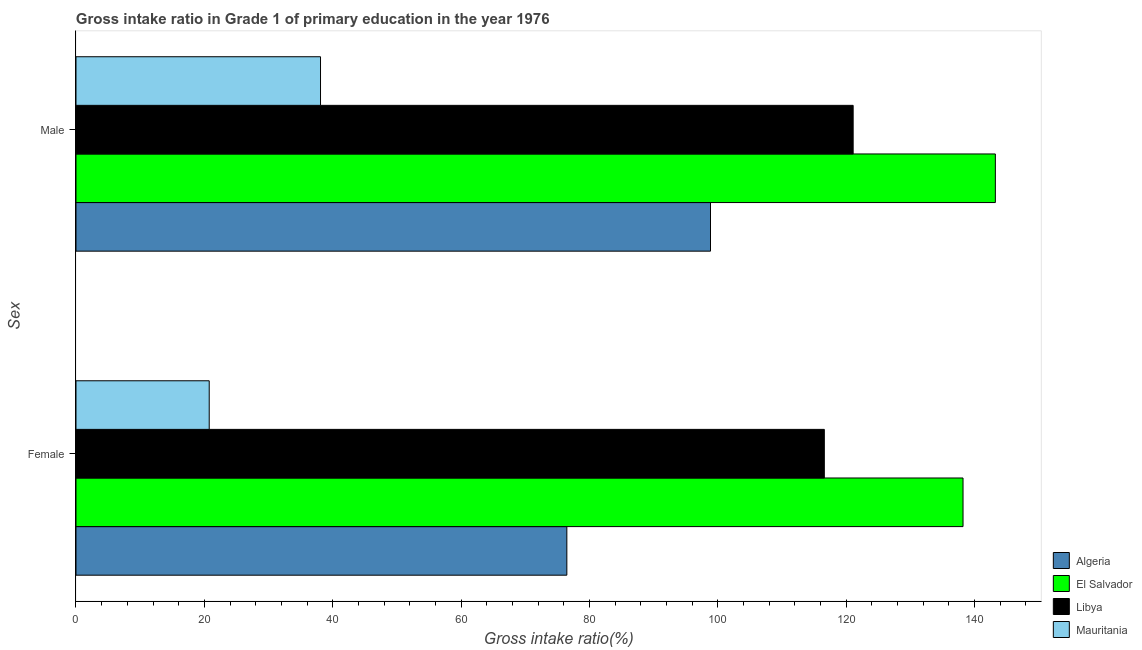How many different coloured bars are there?
Offer a terse response. 4. Are the number of bars per tick equal to the number of legend labels?
Give a very brief answer. Yes. How many bars are there on the 1st tick from the top?
Ensure brevity in your answer.  4. What is the gross intake ratio(male) in Libya?
Your answer should be compact. 121.1. Across all countries, what is the maximum gross intake ratio(female)?
Ensure brevity in your answer.  138.22. Across all countries, what is the minimum gross intake ratio(male)?
Provide a short and direct response. 38.1. In which country was the gross intake ratio(male) maximum?
Provide a short and direct response. El Salvador. In which country was the gross intake ratio(female) minimum?
Your answer should be very brief. Mauritania. What is the total gross intake ratio(female) in the graph?
Keep it short and to the point. 352.07. What is the difference between the gross intake ratio(male) in Libya and that in El Salvador?
Keep it short and to the point. -22.16. What is the difference between the gross intake ratio(female) in Algeria and the gross intake ratio(male) in Libya?
Offer a very short reply. -44.61. What is the average gross intake ratio(male) per country?
Offer a terse response. 100.33. What is the difference between the gross intake ratio(male) and gross intake ratio(female) in Algeria?
Your answer should be compact. 22.39. What is the ratio of the gross intake ratio(female) in Mauritania to that in Algeria?
Your answer should be very brief. 0.27. Is the gross intake ratio(female) in Algeria less than that in Mauritania?
Keep it short and to the point. No. What does the 2nd bar from the top in Female represents?
Ensure brevity in your answer.  Libya. What does the 4th bar from the bottom in Female represents?
Your response must be concise. Mauritania. How many bars are there?
Your response must be concise. 8. How many countries are there in the graph?
Ensure brevity in your answer.  4. Does the graph contain grids?
Offer a terse response. No. Where does the legend appear in the graph?
Keep it short and to the point. Bottom right. How many legend labels are there?
Provide a short and direct response. 4. How are the legend labels stacked?
Offer a terse response. Vertical. What is the title of the graph?
Give a very brief answer. Gross intake ratio in Grade 1 of primary education in the year 1976. What is the label or title of the X-axis?
Make the answer very short. Gross intake ratio(%). What is the label or title of the Y-axis?
Your answer should be very brief. Sex. What is the Gross intake ratio(%) of Algeria in Female?
Provide a short and direct response. 76.48. What is the Gross intake ratio(%) in El Salvador in Female?
Make the answer very short. 138.22. What is the Gross intake ratio(%) of Libya in Female?
Keep it short and to the point. 116.61. What is the Gross intake ratio(%) in Mauritania in Female?
Offer a very short reply. 20.76. What is the Gross intake ratio(%) in Algeria in Male?
Your response must be concise. 98.87. What is the Gross intake ratio(%) in El Salvador in Male?
Offer a very short reply. 143.26. What is the Gross intake ratio(%) of Libya in Male?
Your answer should be compact. 121.1. What is the Gross intake ratio(%) in Mauritania in Male?
Give a very brief answer. 38.1. Across all Sex, what is the maximum Gross intake ratio(%) of Algeria?
Offer a terse response. 98.87. Across all Sex, what is the maximum Gross intake ratio(%) in El Salvador?
Provide a succinct answer. 143.26. Across all Sex, what is the maximum Gross intake ratio(%) of Libya?
Your answer should be very brief. 121.1. Across all Sex, what is the maximum Gross intake ratio(%) of Mauritania?
Provide a short and direct response. 38.1. Across all Sex, what is the minimum Gross intake ratio(%) of Algeria?
Provide a succinct answer. 76.48. Across all Sex, what is the minimum Gross intake ratio(%) in El Salvador?
Make the answer very short. 138.22. Across all Sex, what is the minimum Gross intake ratio(%) in Libya?
Ensure brevity in your answer.  116.61. Across all Sex, what is the minimum Gross intake ratio(%) of Mauritania?
Ensure brevity in your answer.  20.76. What is the total Gross intake ratio(%) in Algeria in the graph?
Your answer should be very brief. 175.36. What is the total Gross intake ratio(%) of El Salvador in the graph?
Keep it short and to the point. 281.47. What is the total Gross intake ratio(%) in Libya in the graph?
Keep it short and to the point. 237.7. What is the total Gross intake ratio(%) of Mauritania in the graph?
Provide a short and direct response. 58.86. What is the difference between the Gross intake ratio(%) of Algeria in Female and that in Male?
Provide a short and direct response. -22.39. What is the difference between the Gross intake ratio(%) of El Salvador in Female and that in Male?
Give a very brief answer. -5.04. What is the difference between the Gross intake ratio(%) in Libya in Female and that in Male?
Your answer should be very brief. -4.49. What is the difference between the Gross intake ratio(%) in Mauritania in Female and that in Male?
Keep it short and to the point. -17.34. What is the difference between the Gross intake ratio(%) in Algeria in Female and the Gross intake ratio(%) in El Salvador in Male?
Your answer should be very brief. -66.77. What is the difference between the Gross intake ratio(%) of Algeria in Female and the Gross intake ratio(%) of Libya in Male?
Your answer should be compact. -44.61. What is the difference between the Gross intake ratio(%) of Algeria in Female and the Gross intake ratio(%) of Mauritania in Male?
Ensure brevity in your answer.  38.38. What is the difference between the Gross intake ratio(%) of El Salvador in Female and the Gross intake ratio(%) of Libya in Male?
Your answer should be very brief. 17.12. What is the difference between the Gross intake ratio(%) in El Salvador in Female and the Gross intake ratio(%) in Mauritania in Male?
Your answer should be compact. 100.12. What is the difference between the Gross intake ratio(%) of Libya in Female and the Gross intake ratio(%) of Mauritania in Male?
Your answer should be compact. 78.5. What is the average Gross intake ratio(%) in Algeria per Sex?
Provide a succinct answer. 87.68. What is the average Gross intake ratio(%) in El Salvador per Sex?
Provide a short and direct response. 140.74. What is the average Gross intake ratio(%) of Libya per Sex?
Provide a succinct answer. 118.85. What is the average Gross intake ratio(%) in Mauritania per Sex?
Make the answer very short. 29.43. What is the difference between the Gross intake ratio(%) of Algeria and Gross intake ratio(%) of El Salvador in Female?
Provide a succinct answer. -61.73. What is the difference between the Gross intake ratio(%) of Algeria and Gross intake ratio(%) of Libya in Female?
Make the answer very short. -40.12. What is the difference between the Gross intake ratio(%) in Algeria and Gross intake ratio(%) in Mauritania in Female?
Provide a short and direct response. 55.73. What is the difference between the Gross intake ratio(%) of El Salvador and Gross intake ratio(%) of Libya in Female?
Your answer should be compact. 21.61. What is the difference between the Gross intake ratio(%) in El Salvador and Gross intake ratio(%) in Mauritania in Female?
Ensure brevity in your answer.  117.46. What is the difference between the Gross intake ratio(%) of Libya and Gross intake ratio(%) of Mauritania in Female?
Provide a short and direct response. 95.85. What is the difference between the Gross intake ratio(%) of Algeria and Gross intake ratio(%) of El Salvador in Male?
Your response must be concise. -44.38. What is the difference between the Gross intake ratio(%) of Algeria and Gross intake ratio(%) of Libya in Male?
Provide a short and direct response. -22.23. What is the difference between the Gross intake ratio(%) in Algeria and Gross intake ratio(%) in Mauritania in Male?
Keep it short and to the point. 60.77. What is the difference between the Gross intake ratio(%) of El Salvador and Gross intake ratio(%) of Libya in Male?
Give a very brief answer. 22.16. What is the difference between the Gross intake ratio(%) in El Salvador and Gross intake ratio(%) in Mauritania in Male?
Keep it short and to the point. 105.15. What is the difference between the Gross intake ratio(%) of Libya and Gross intake ratio(%) of Mauritania in Male?
Give a very brief answer. 83. What is the ratio of the Gross intake ratio(%) of Algeria in Female to that in Male?
Provide a succinct answer. 0.77. What is the ratio of the Gross intake ratio(%) in El Salvador in Female to that in Male?
Make the answer very short. 0.96. What is the ratio of the Gross intake ratio(%) in Libya in Female to that in Male?
Your answer should be compact. 0.96. What is the ratio of the Gross intake ratio(%) of Mauritania in Female to that in Male?
Provide a succinct answer. 0.54. What is the difference between the highest and the second highest Gross intake ratio(%) in Algeria?
Your answer should be very brief. 22.39. What is the difference between the highest and the second highest Gross intake ratio(%) of El Salvador?
Your response must be concise. 5.04. What is the difference between the highest and the second highest Gross intake ratio(%) of Libya?
Give a very brief answer. 4.49. What is the difference between the highest and the second highest Gross intake ratio(%) of Mauritania?
Keep it short and to the point. 17.34. What is the difference between the highest and the lowest Gross intake ratio(%) in Algeria?
Offer a terse response. 22.39. What is the difference between the highest and the lowest Gross intake ratio(%) in El Salvador?
Offer a very short reply. 5.04. What is the difference between the highest and the lowest Gross intake ratio(%) in Libya?
Offer a very short reply. 4.49. What is the difference between the highest and the lowest Gross intake ratio(%) of Mauritania?
Provide a short and direct response. 17.34. 